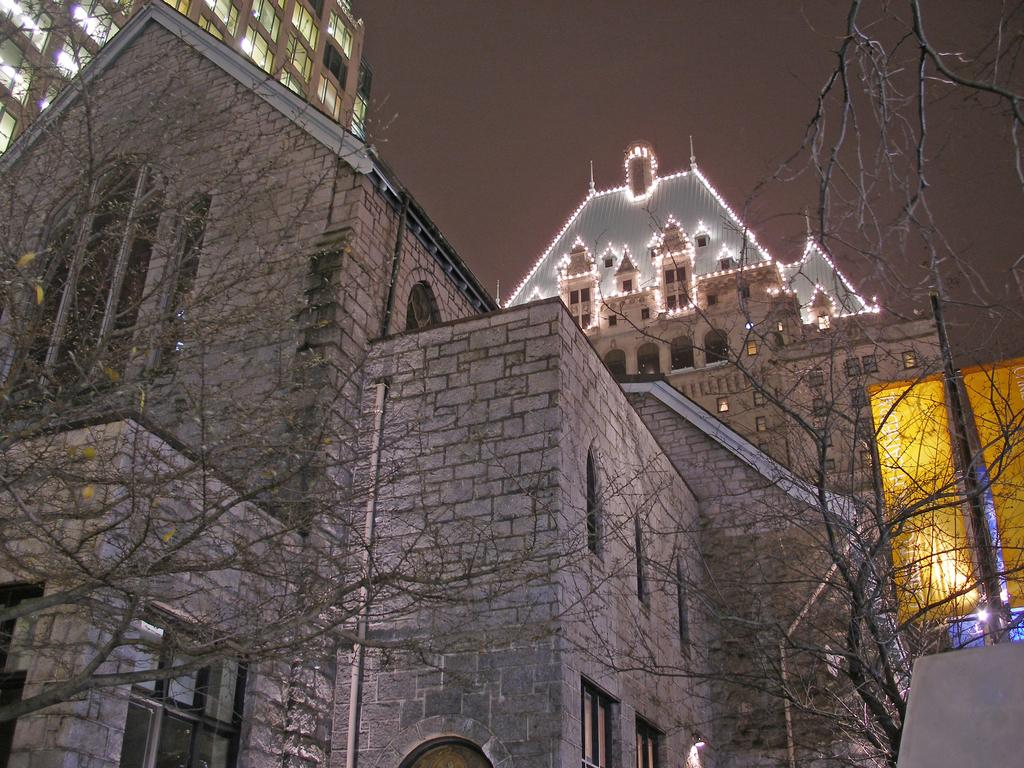What is the main feature of the building in the image? The building is decorated with lights. Are there any other buildings in the image? Yes, there is another building beside the one with lights. What can be seen on either side of the building with lights? There are dried trees on either side of the building with lights. What type of glove is hanging from the tree on the left side of the image? There is no glove present in the image; it only features buildings and dried trees. 